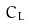<formula> <loc_0><loc_0><loc_500><loc_500>\ C _ { L }</formula> 